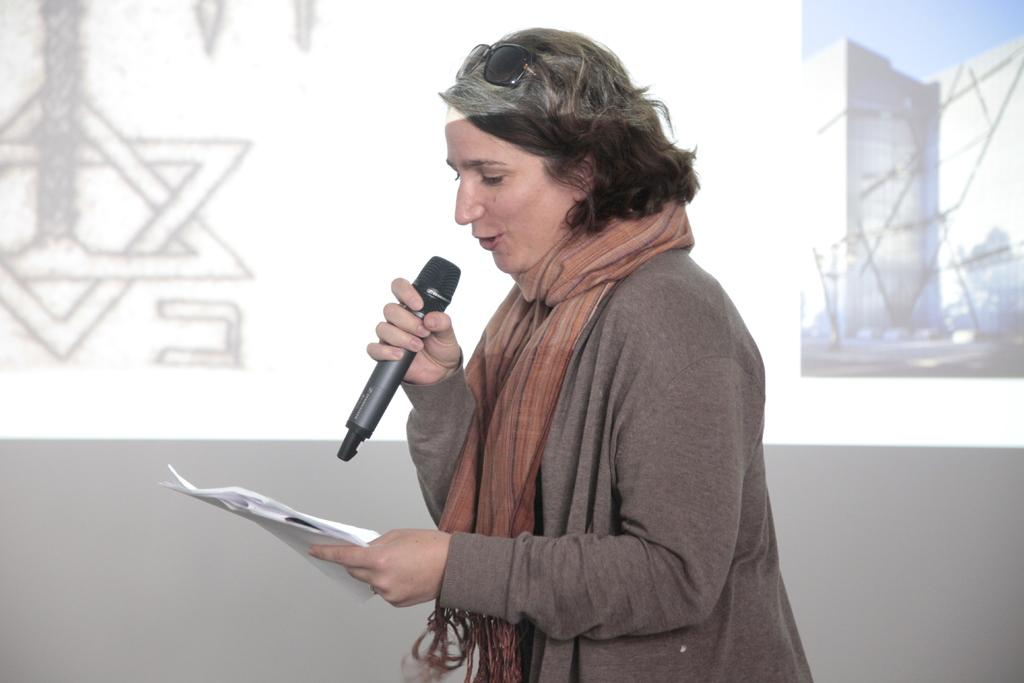Who is the main subject in the image? There is a woman in the image. Where is the woman positioned in the image? The woman is standing in the middle. What is the woman holding in the image? The woman is holding a microphone. What else is the woman holding in the image? The woman has some papers in her hand. What type of mist can be seen surrounding the woman in the image? There is no mist present in the image; it only features the woman, a microphone, and some papers. 